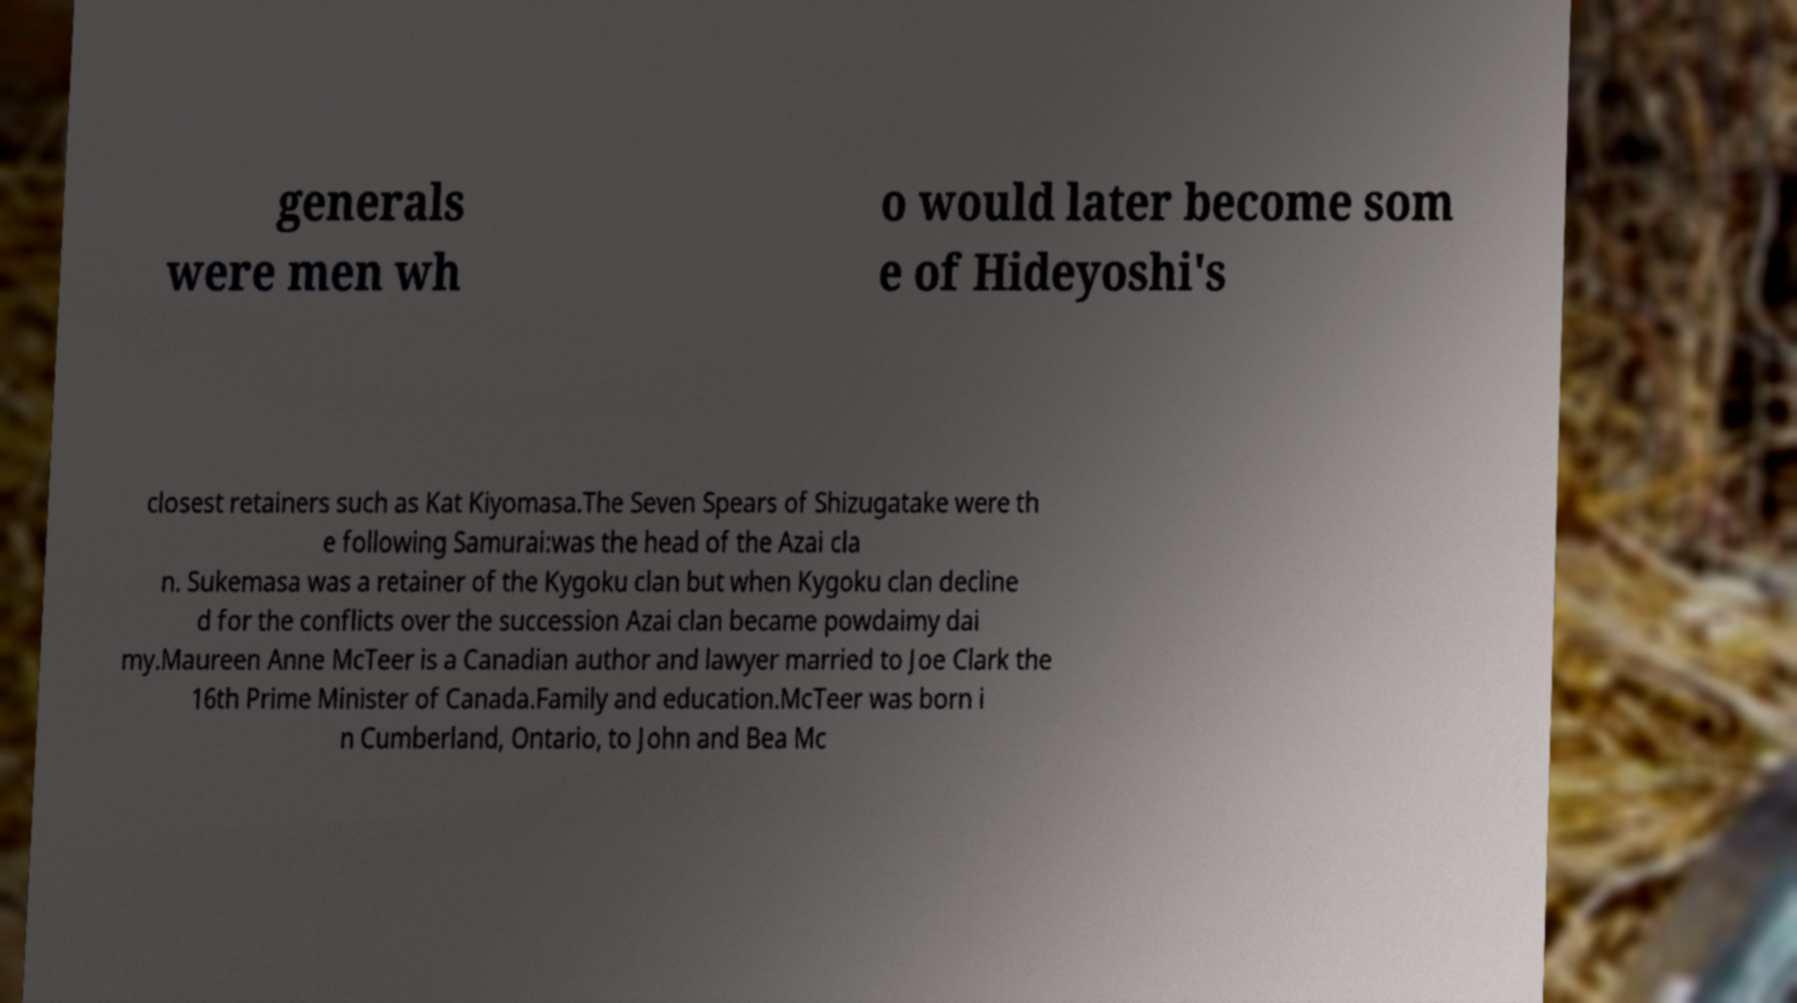I need the written content from this picture converted into text. Can you do that? generals were men wh o would later become som e of Hideyoshi's closest retainers such as Kat Kiyomasa.The Seven Spears of Shizugatake were th e following Samurai:was the head of the Azai cla n. Sukemasa was a retainer of the Kygoku clan but when Kygoku clan decline d for the conflicts over the succession Azai clan became powdaimy dai my.Maureen Anne McTeer is a Canadian author and lawyer married to Joe Clark the 16th Prime Minister of Canada.Family and education.McTeer was born i n Cumberland, Ontario, to John and Bea Mc 